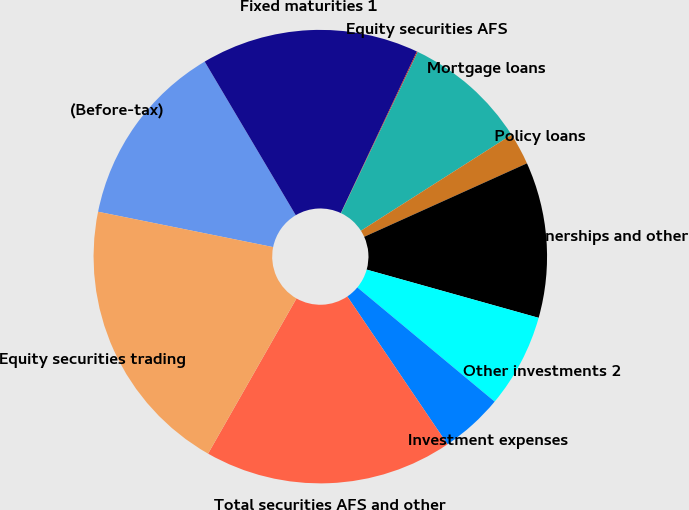Convert chart. <chart><loc_0><loc_0><loc_500><loc_500><pie_chart><fcel>(Before-tax)<fcel>Fixed maturities 1<fcel>Equity securities AFS<fcel>Mortgage loans<fcel>Policy loans<fcel>Limited partnerships and other<fcel>Other investments 2<fcel>Investment expenses<fcel>Total securities AFS and other<fcel>Equity securities trading<nl><fcel>13.31%<fcel>15.52%<fcel>0.07%<fcel>8.9%<fcel>2.28%<fcel>11.1%<fcel>6.69%<fcel>4.48%<fcel>17.72%<fcel>19.93%<nl></chart> 